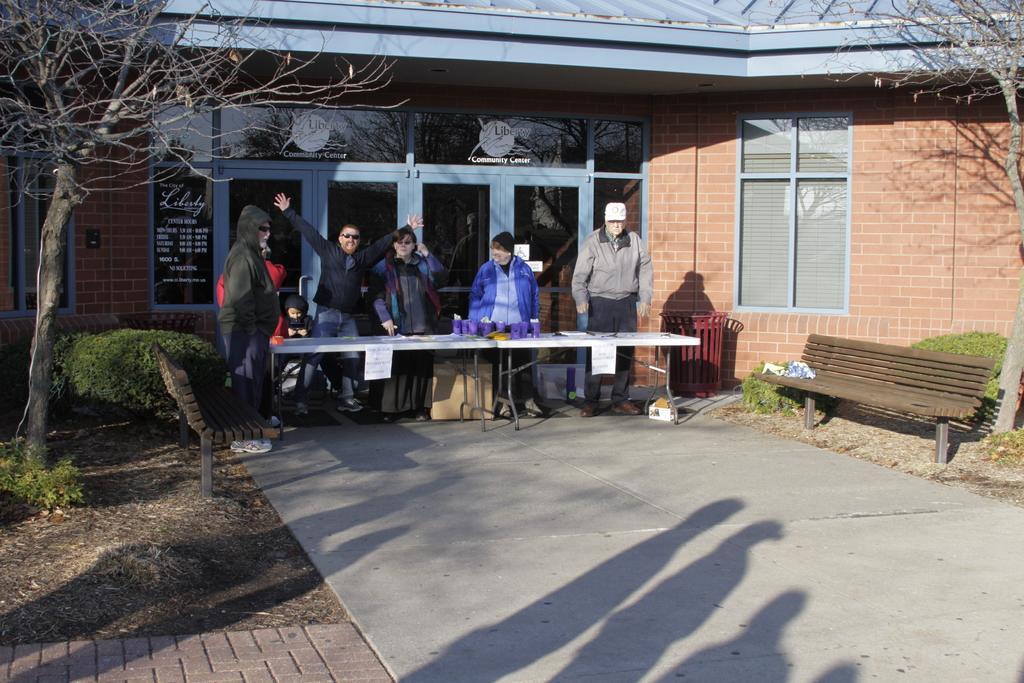How would you summarize this image in a sentence or two? In this image we can see people, tables, papers, benches, and objects. There is a road. Here we can see plants and bare trees. In the background we can see a house, door, and windows. 